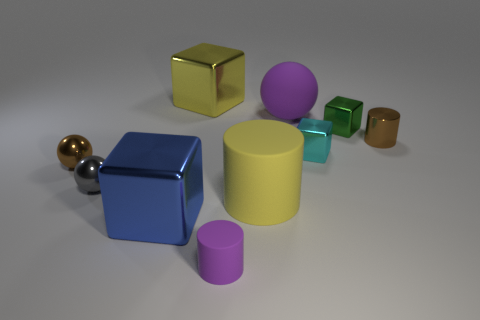Subtract all tiny green blocks. How many blocks are left? 3 Subtract all yellow cubes. How many cubes are left? 3 Subtract all green cylinders. Subtract all yellow spheres. How many cylinders are left? 3 Subtract all blue cubes. How many yellow cylinders are left? 1 Subtract all tiny cylinders. Subtract all big rubber cylinders. How many objects are left? 7 Add 3 tiny green metallic objects. How many tiny green metallic objects are left? 4 Add 7 yellow blocks. How many yellow blocks exist? 8 Subtract 1 green blocks. How many objects are left? 9 Subtract all cubes. How many objects are left? 6 Subtract 4 cubes. How many cubes are left? 0 